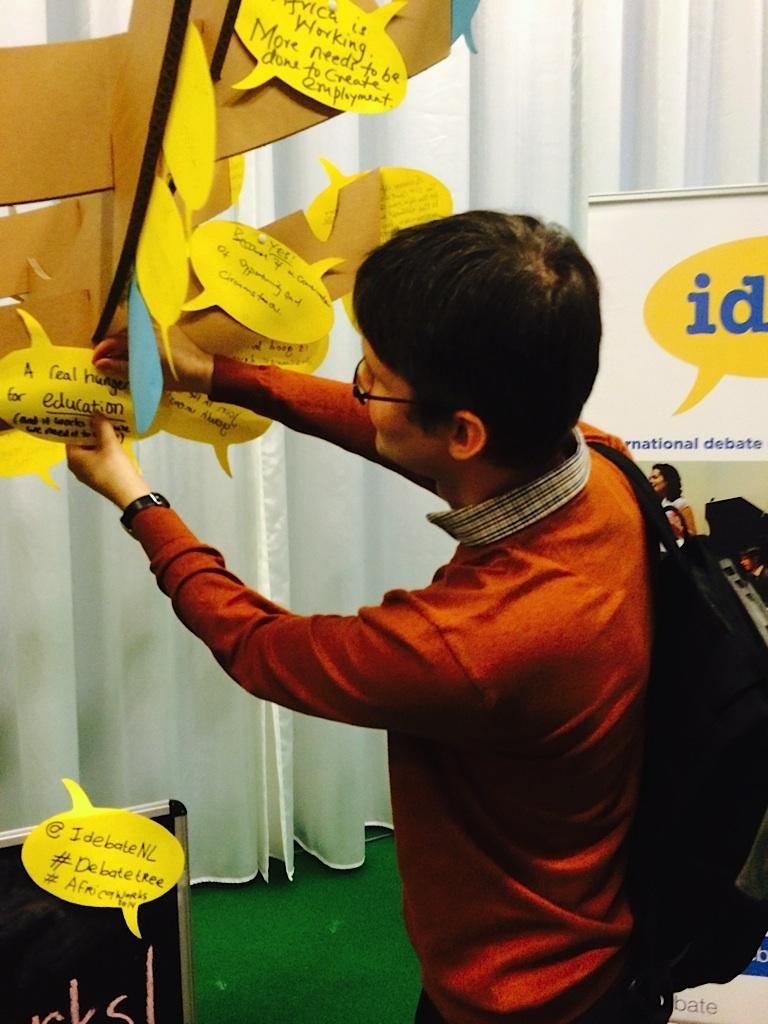What can be seen in the image related to a person? There is a person in the image. What accessories is the person wearing? The person is wearing specs and a watch. What is the person carrying in the image? The person is carrying a bag. What is on the board in the image? There is a board with papers in the image, and there is text on the papers. What can be seen in the background of the image? There are curtains in the background of the image. Reasoning: Let'g: Let's think step by step in order to produce the conversation. We start by identifying the main subject in the image, which is the person. Then, we describe the accessories the person is wearing and the object they are carrying. Next, we focus on the board with papers and the text on them. Finally, we mention the background details, specifically the curtains. Each question is designed to elicit a specific detail about the image that is known from the provided facts. Absurd Question/Answer: What type of clouds can be seen in the image? There are no clouds visible in the image; it is an indoor scene with curtains in the background. How does the person's behavior change throughout the image? The image is a still photograph, so it does not depict any changes in the person's behavior. 